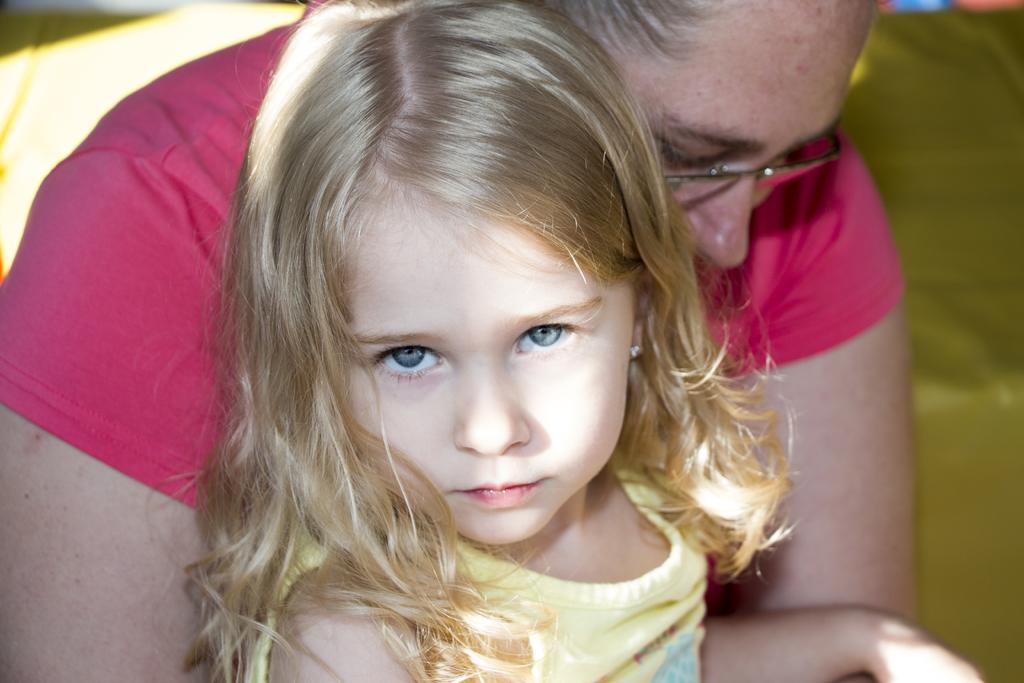Who are the people in the image? There is a girl and a woman in the image. Can you describe the green color object in the background? There is a green color object in the background of the image, but its specific details are not mentioned. What is the relationship between the girl and the woman in the image? The relationship between the girl and the woman is not mentioned in the provided facts. What type of meat is being cooked by the girl in the image? There is no meat or cooking activity present in the image. 